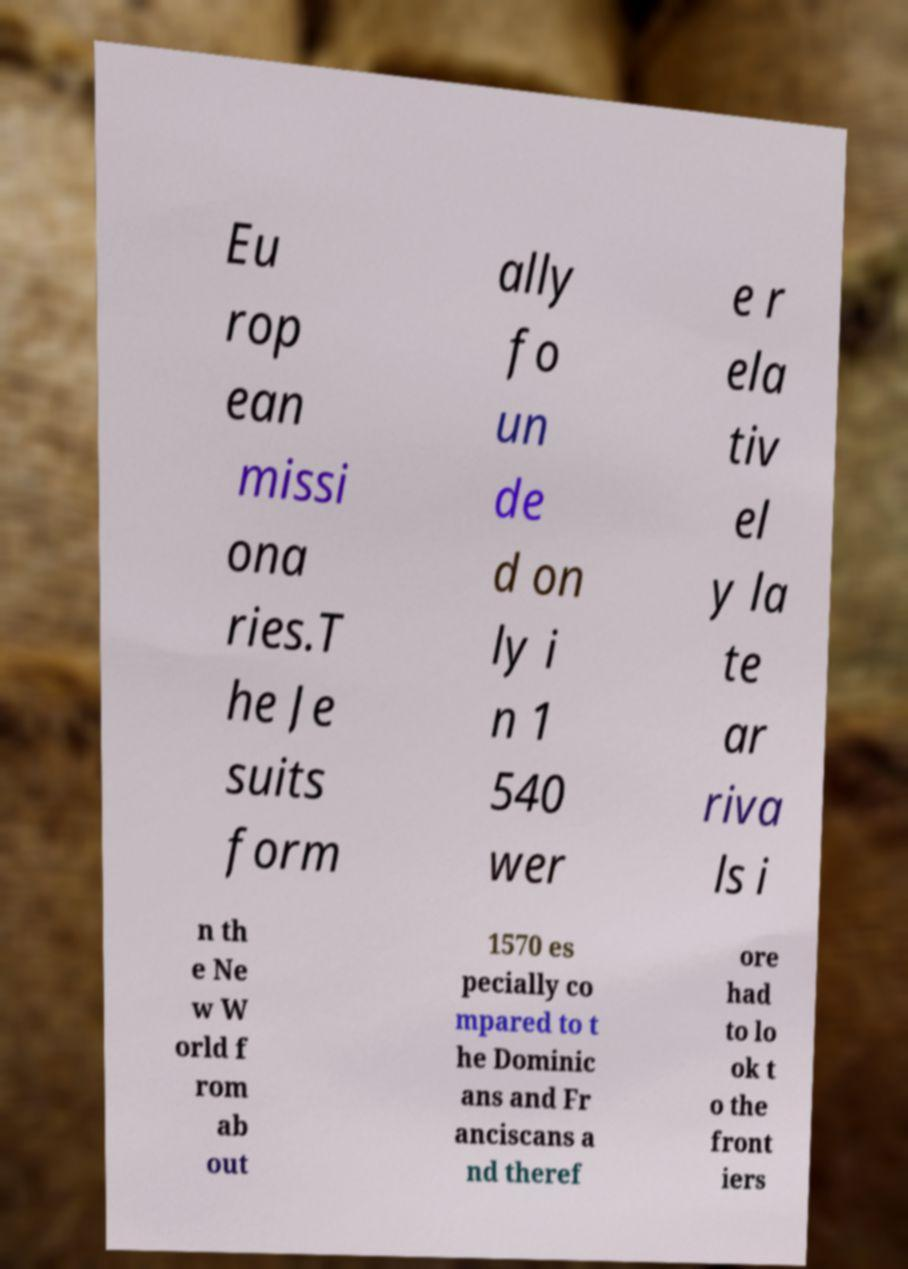For documentation purposes, I need the text within this image transcribed. Could you provide that? Eu rop ean missi ona ries.T he Je suits form ally fo un de d on ly i n 1 540 wer e r ela tiv el y la te ar riva ls i n th e Ne w W orld f rom ab out 1570 es pecially co mpared to t he Dominic ans and Fr anciscans a nd theref ore had to lo ok t o the front iers 